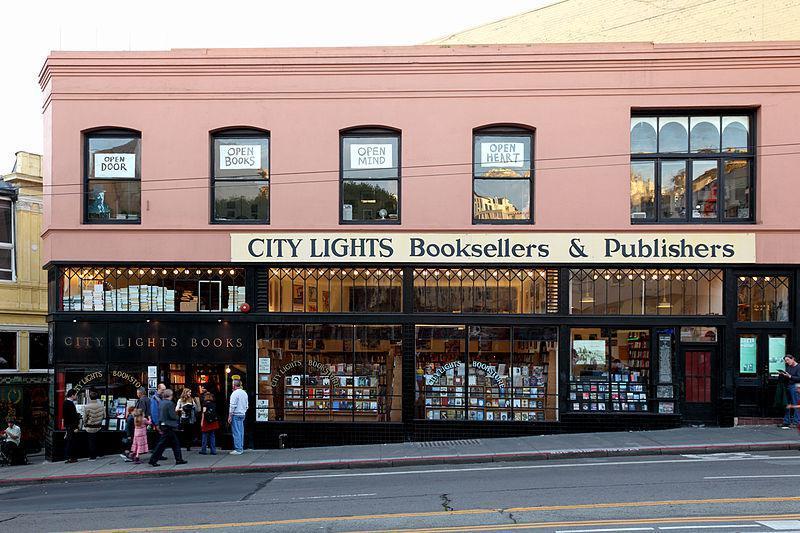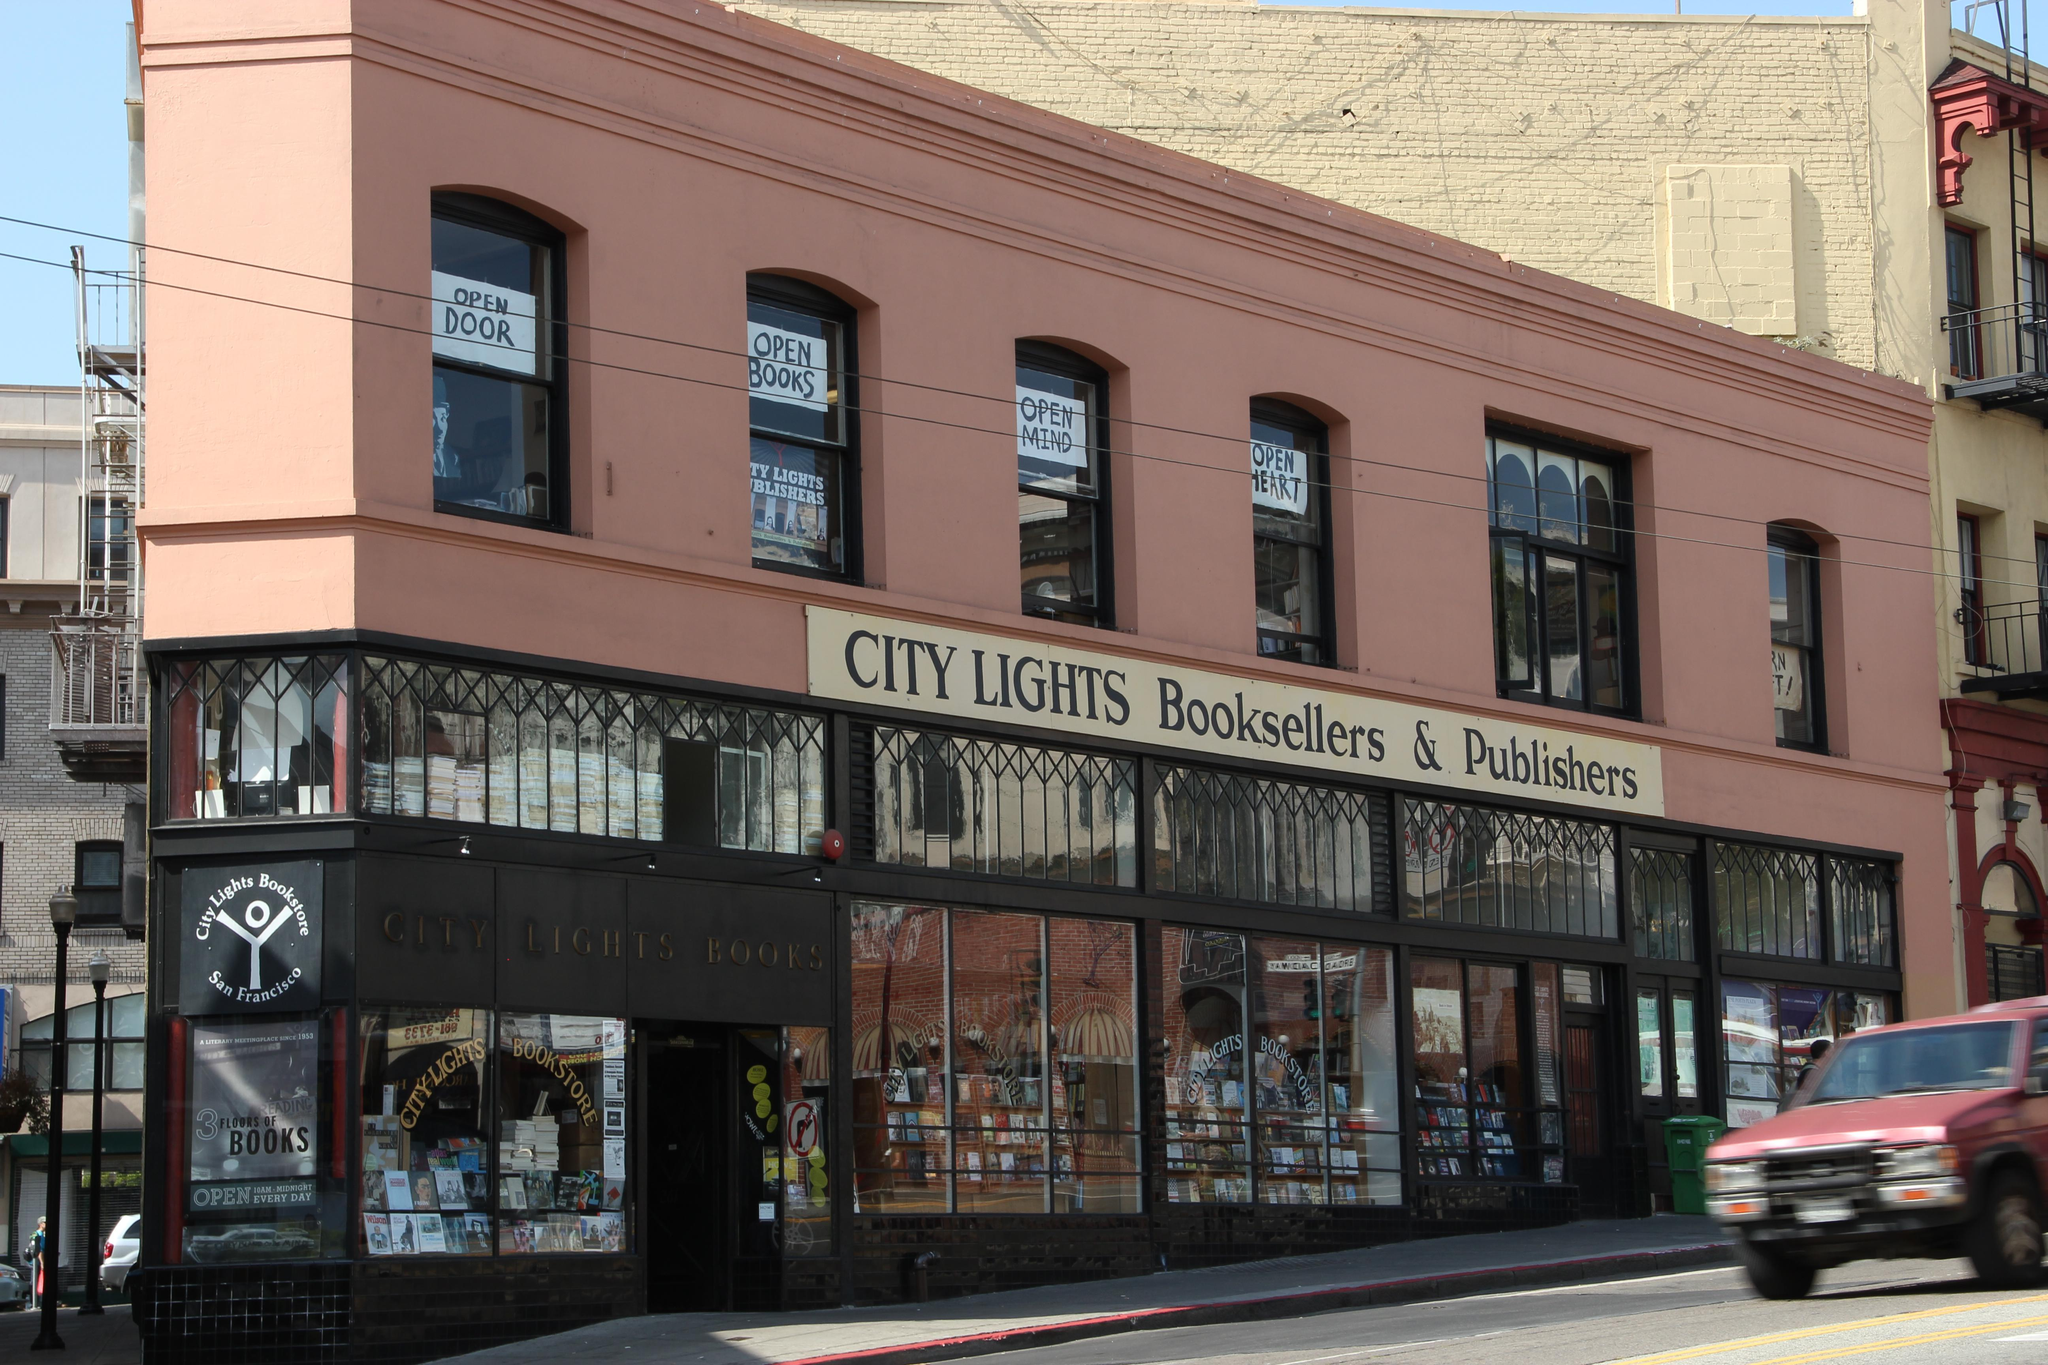The first image is the image on the left, the second image is the image on the right. Assess this claim about the two images: "People are walking past the shop in the image on the right.". Correct or not? Answer yes or no. No. The first image is the image on the left, the second image is the image on the right. Analyze the images presented: Is the assertion "Left and right images show the same store exterior, and each storefront has a row of windows with tops that are at least slightly arched." valid? Answer yes or no. Yes. 